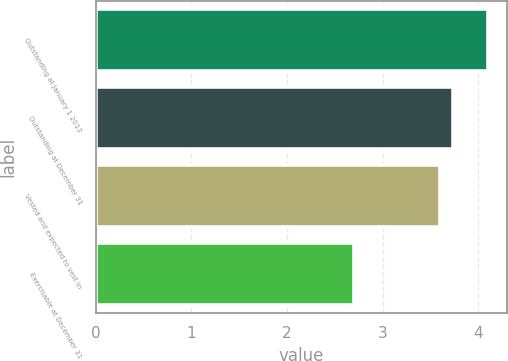<chart> <loc_0><loc_0><loc_500><loc_500><bar_chart><fcel>Outstanding at January 1 2013<fcel>Outstanding at December 31<fcel>Vested and expected to vest in<fcel>Exercisable at December 31<nl><fcel>4.1<fcel>3.74<fcel>3.6<fcel>2.7<nl></chart> 